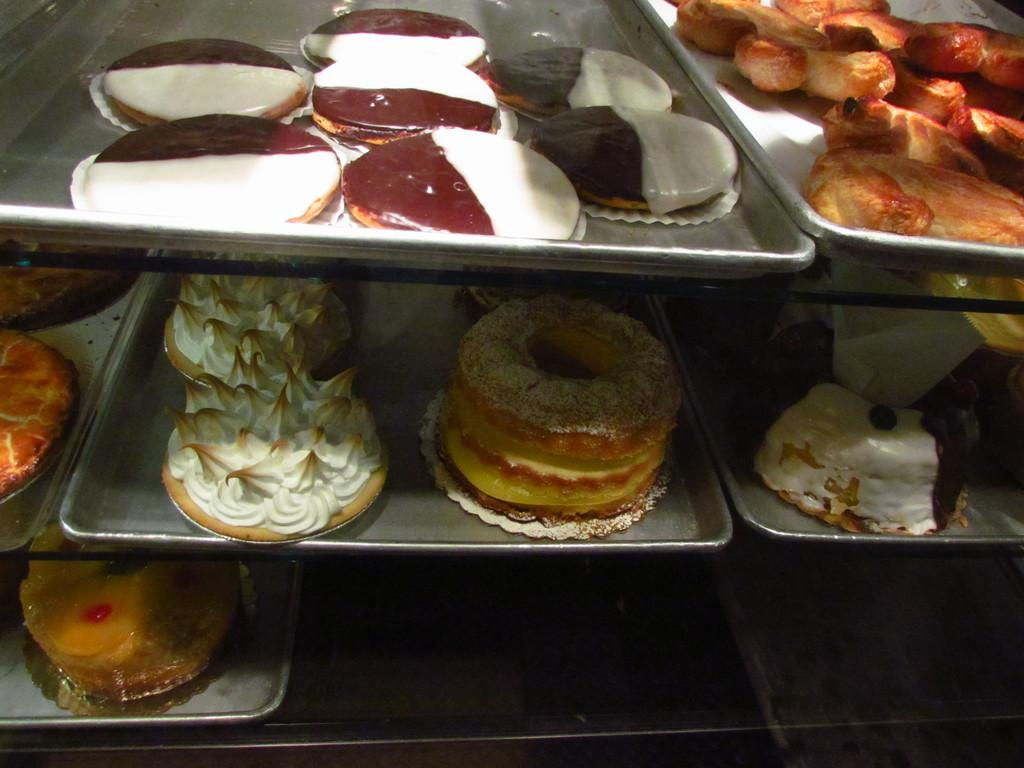What can be seen in the image? There are food items in the image. How are the food items arranged or organized? The food items are kept in trays. Can you tell me how the horse is talking to the food items in the image? There is no horse or talking in the image; it only features food items arranged in trays. 